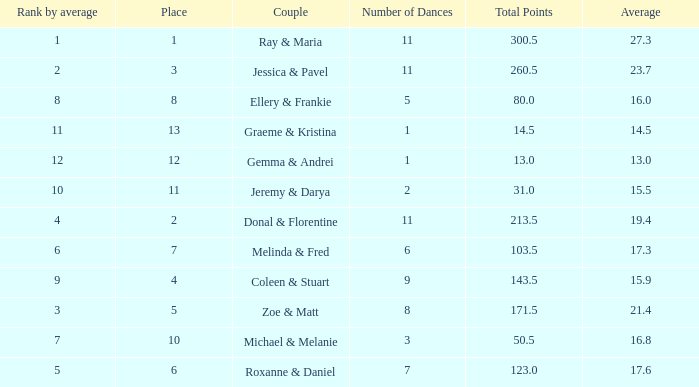If the total points is 50.5, what is the total number of dances? 1.0. 